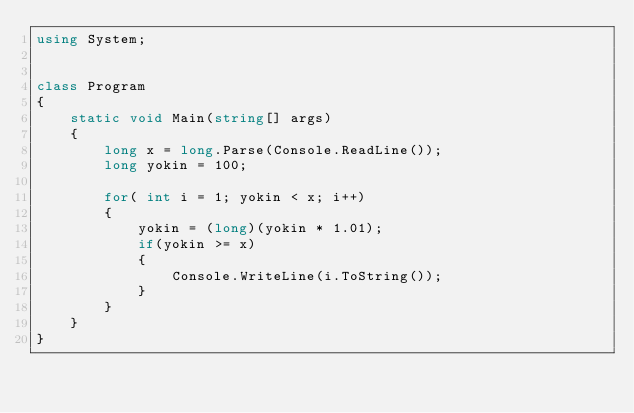Convert code to text. <code><loc_0><loc_0><loc_500><loc_500><_C#_>using System;


class Program
{
    static void Main(string[] args)
    {
        long x = long.Parse(Console.ReadLine());
        long yokin = 100;

        for( int i = 1; yokin < x; i++)
        {
            yokin = (long)(yokin * 1.01);
            if(yokin >= x)
            {
                Console.WriteLine(i.ToString());
            }
        }
    }
}
</code> 